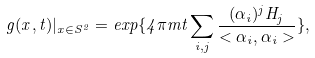Convert formula to latex. <formula><loc_0><loc_0><loc_500><loc_500>g ( { x } , t ) | _ { x \in S ^ { 2 } } = e x p \{ 4 \pi m t \sum _ { i , j } \frac { ( \alpha _ { i } ) ^ { j } H _ { j } } { < \alpha _ { i } , \alpha _ { i } > } \} ,</formula> 